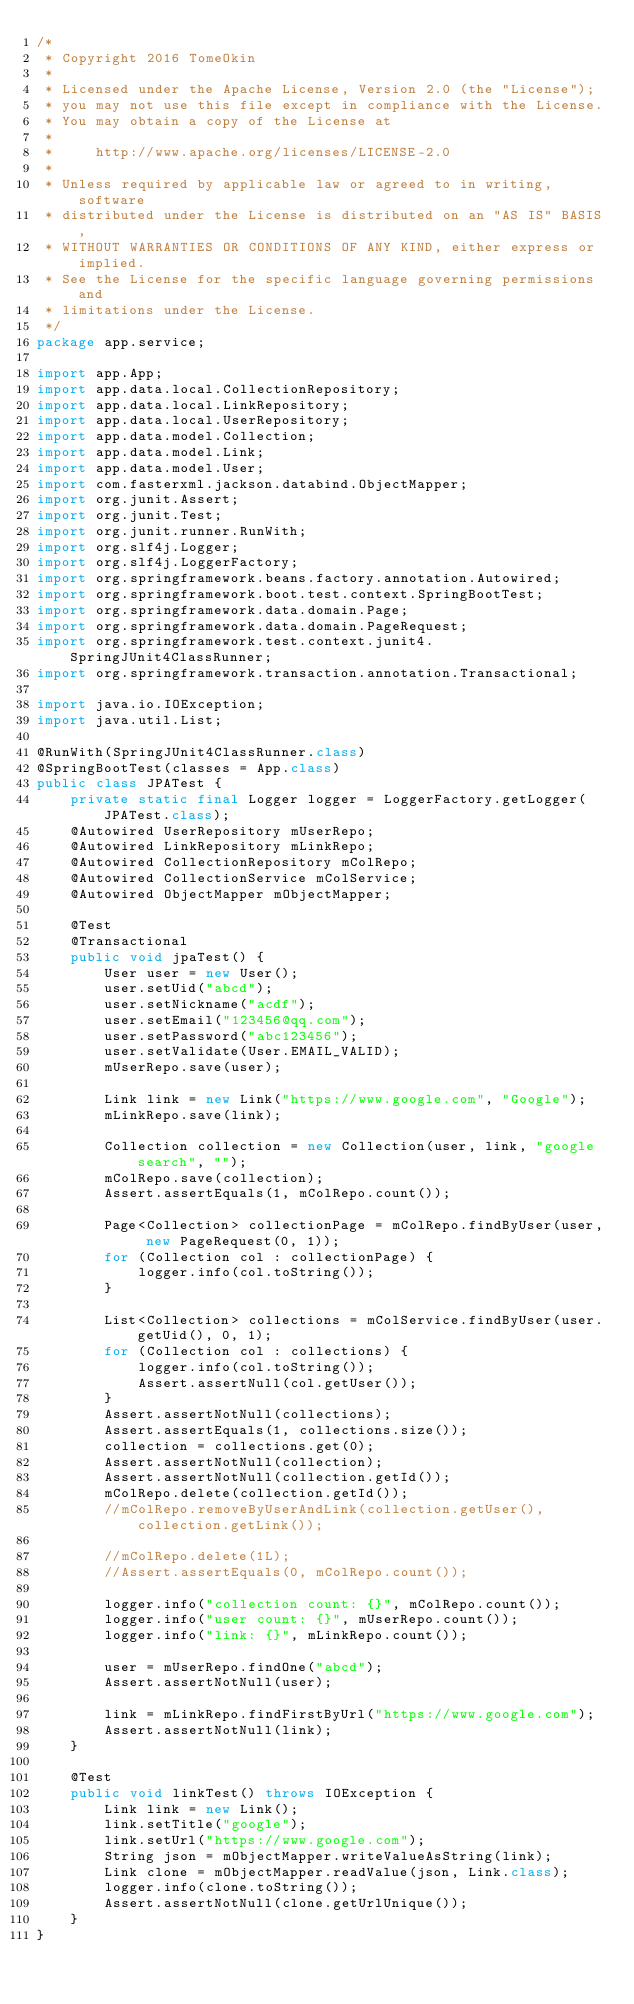<code> <loc_0><loc_0><loc_500><loc_500><_Java_>/*
 * Copyright 2016 TomeOkin
 * 
 * Licensed under the Apache License, Version 2.0 (the "License");
 * you may not use this file except in compliance with the License.
 * You may obtain a copy of the License at
 * 
 *     http://www.apache.org/licenses/LICENSE-2.0
 * 
 * Unless required by applicable law or agreed to in writing, software
 * distributed under the License is distributed on an "AS IS" BASIS,
 * WITHOUT WARRANTIES OR CONDITIONS OF ANY KIND, either express or implied.
 * See the License for the specific language governing permissions and
 * limitations under the License.
 */
package app.service;

import app.App;
import app.data.local.CollectionRepository;
import app.data.local.LinkRepository;
import app.data.local.UserRepository;
import app.data.model.Collection;
import app.data.model.Link;
import app.data.model.User;
import com.fasterxml.jackson.databind.ObjectMapper;
import org.junit.Assert;
import org.junit.Test;
import org.junit.runner.RunWith;
import org.slf4j.Logger;
import org.slf4j.LoggerFactory;
import org.springframework.beans.factory.annotation.Autowired;
import org.springframework.boot.test.context.SpringBootTest;
import org.springframework.data.domain.Page;
import org.springframework.data.domain.PageRequest;
import org.springframework.test.context.junit4.SpringJUnit4ClassRunner;
import org.springframework.transaction.annotation.Transactional;

import java.io.IOException;
import java.util.List;

@RunWith(SpringJUnit4ClassRunner.class)
@SpringBootTest(classes = App.class)
public class JPATest {
    private static final Logger logger = LoggerFactory.getLogger(JPATest.class);
    @Autowired UserRepository mUserRepo;
    @Autowired LinkRepository mLinkRepo;
    @Autowired CollectionRepository mColRepo;
    @Autowired CollectionService mColService;
    @Autowired ObjectMapper mObjectMapper;

    @Test
    @Transactional
    public void jpaTest() {
        User user = new User();
        user.setUid("abcd");
        user.setNickname("acdf");
        user.setEmail("123456@qq.com");
        user.setPassword("abc123456");
        user.setValidate(User.EMAIL_VALID);
        mUserRepo.save(user);

        Link link = new Link("https://www.google.com", "Google");
        mLinkRepo.save(link);

        Collection collection = new Collection(user, link, "google search", "");
        mColRepo.save(collection);
        Assert.assertEquals(1, mColRepo.count());

        Page<Collection> collectionPage = mColRepo.findByUser(user, new PageRequest(0, 1));
        for (Collection col : collectionPage) {
            logger.info(col.toString());
        }

        List<Collection> collections = mColService.findByUser(user.getUid(), 0, 1);
        for (Collection col : collections) {
            logger.info(col.toString());
            Assert.assertNull(col.getUser());
        }
        Assert.assertNotNull(collections);
        Assert.assertEquals(1, collections.size());
        collection = collections.get(0);
        Assert.assertNotNull(collection);
        Assert.assertNotNull(collection.getId());
        mColRepo.delete(collection.getId());
        //mColRepo.removeByUserAndLink(collection.getUser(), collection.getLink());

        //mColRepo.delete(1L);
        //Assert.assertEquals(0, mColRepo.count());

        logger.info("collection count: {}", mColRepo.count());
        logger.info("user count: {}", mUserRepo.count());
        logger.info("link: {}", mLinkRepo.count());

        user = mUserRepo.findOne("abcd");
        Assert.assertNotNull(user);

        link = mLinkRepo.findFirstByUrl("https://www.google.com");
        Assert.assertNotNull(link);
    }

    @Test
    public void linkTest() throws IOException {
        Link link = new Link();
        link.setTitle("google");
        link.setUrl("https://www.google.com");
        String json = mObjectMapper.writeValueAsString(link);
        Link clone = mObjectMapper.readValue(json, Link.class);
        logger.info(clone.toString());
        Assert.assertNotNull(clone.getUrlUnique());
    }
}
</code> 